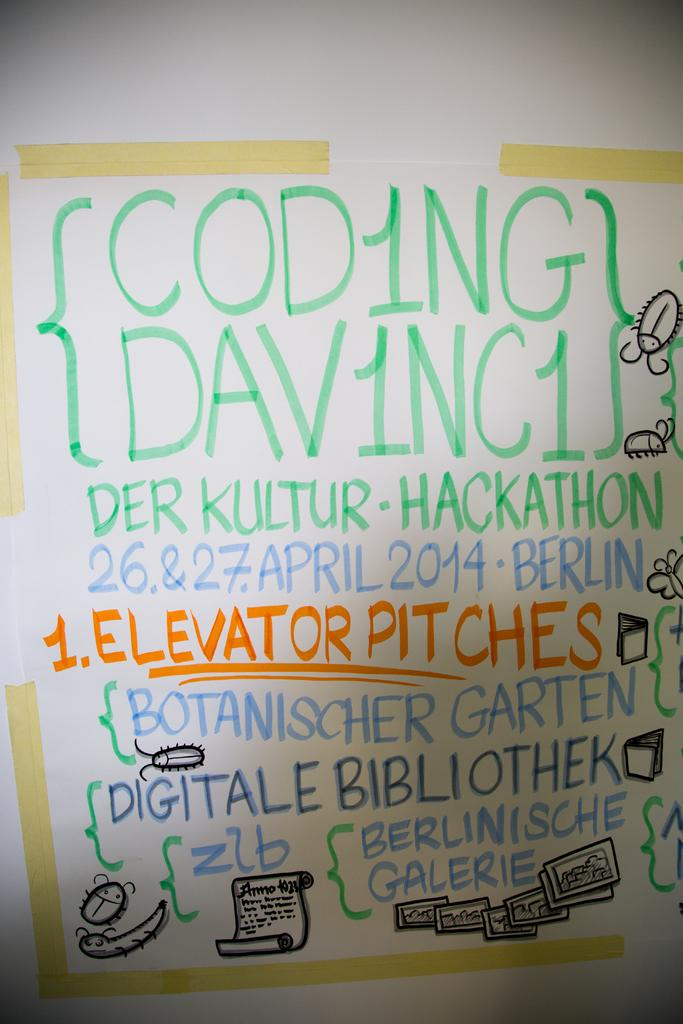Provide a one-sentence caption for the provided image. A white board with hand written notes that say Der Kultur-Hackathon. 